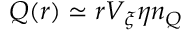Convert formula to latex. <formula><loc_0><loc_0><loc_500><loc_500>Q ( r ) \simeq r V _ { \xi } \eta n _ { Q }</formula> 